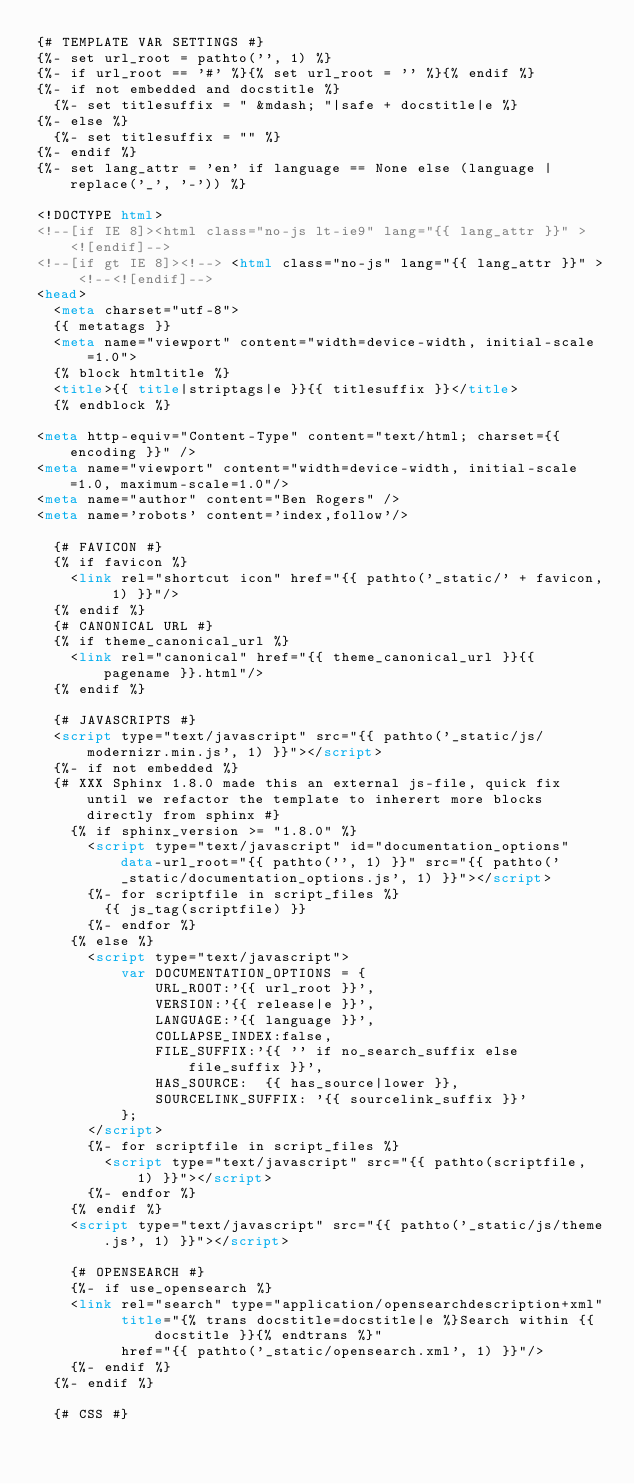<code> <loc_0><loc_0><loc_500><loc_500><_HTML_>{# TEMPLATE VAR SETTINGS #}
{%- set url_root = pathto('', 1) %}
{%- if url_root == '#' %}{% set url_root = '' %}{% endif %}
{%- if not embedded and docstitle %}
  {%- set titlesuffix = " &mdash; "|safe + docstitle|e %}
{%- else %}
  {%- set titlesuffix = "" %}
{%- endif %}
{%- set lang_attr = 'en' if language == None else (language | replace('_', '-')) %}

<!DOCTYPE html>
<!--[if IE 8]><html class="no-js lt-ie9" lang="{{ lang_attr }}" > <![endif]-->
<!--[if gt IE 8]><!--> <html class="no-js" lang="{{ lang_attr }}" > <!--<![endif]-->
<head>
  <meta charset="utf-8">
  {{ metatags }}
  <meta name="viewport" content="width=device-width, initial-scale=1.0">
  {% block htmltitle %}
  <title>{{ title|striptags|e }}{{ titlesuffix }}</title>
  {% endblock %}

<meta http-equiv="Content-Type" content="text/html; charset={{ encoding }}" />
<meta name="viewport" content="width=device-width, initial-scale=1.0, maximum-scale=1.0"/>
<meta name="author" content="Ben Rogers" />
<meta name='robots' content='index,follow'/>

  {# FAVICON #}
  {% if favicon %}
    <link rel="shortcut icon" href="{{ pathto('_static/' + favicon, 1) }}"/>
  {% endif %}
  {# CANONICAL URL #}
  {% if theme_canonical_url %}
    <link rel="canonical" href="{{ theme_canonical_url }}{{ pagename }}.html"/>
  {% endif %}

  {# JAVASCRIPTS #}
  <script type="text/javascript" src="{{ pathto('_static/js/modernizr.min.js', 1) }}"></script>
  {%- if not embedded %}
  {# XXX Sphinx 1.8.0 made this an external js-file, quick fix until we refactor the template to inherert more blocks directly from sphinx #}
    {% if sphinx_version >= "1.8.0" %}
      <script type="text/javascript" id="documentation_options" data-url_root="{{ pathto('', 1) }}" src="{{ pathto('_static/documentation_options.js', 1) }}"></script>
      {%- for scriptfile in script_files %}
        {{ js_tag(scriptfile) }}
      {%- endfor %}
    {% else %}
      <script type="text/javascript">
          var DOCUMENTATION_OPTIONS = {
              URL_ROOT:'{{ url_root }}',
              VERSION:'{{ release|e }}',
              LANGUAGE:'{{ language }}',
              COLLAPSE_INDEX:false,
              FILE_SUFFIX:'{{ '' if no_search_suffix else file_suffix }}',
              HAS_SOURCE:  {{ has_source|lower }},
              SOURCELINK_SUFFIX: '{{ sourcelink_suffix }}'
          };
      </script>
      {%- for scriptfile in script_files %}
        <script type="text/javascript" src="{{ pathto(scriptfile, 1) }}"></script>
      {%- endfor %}
    {% endif %}
    <script type="text/javascript" src="{{ pathto('_static/js/theme.js', 1) }}"></script>

    {# OPENSEARCH #}
    {%- if use_opensearch %}
    <link rel="search" type="application/opensearchdescription+xml"
          title="{% trans docstitle=docstitle|e %}Search within {{ docstitle }}{% endtrans %}"
          href="{{ pathto('_static/opensearch.xml', 1) }}"/>
    {%- endif %}
  {%- endif %}

  {# CSS #}</code> 